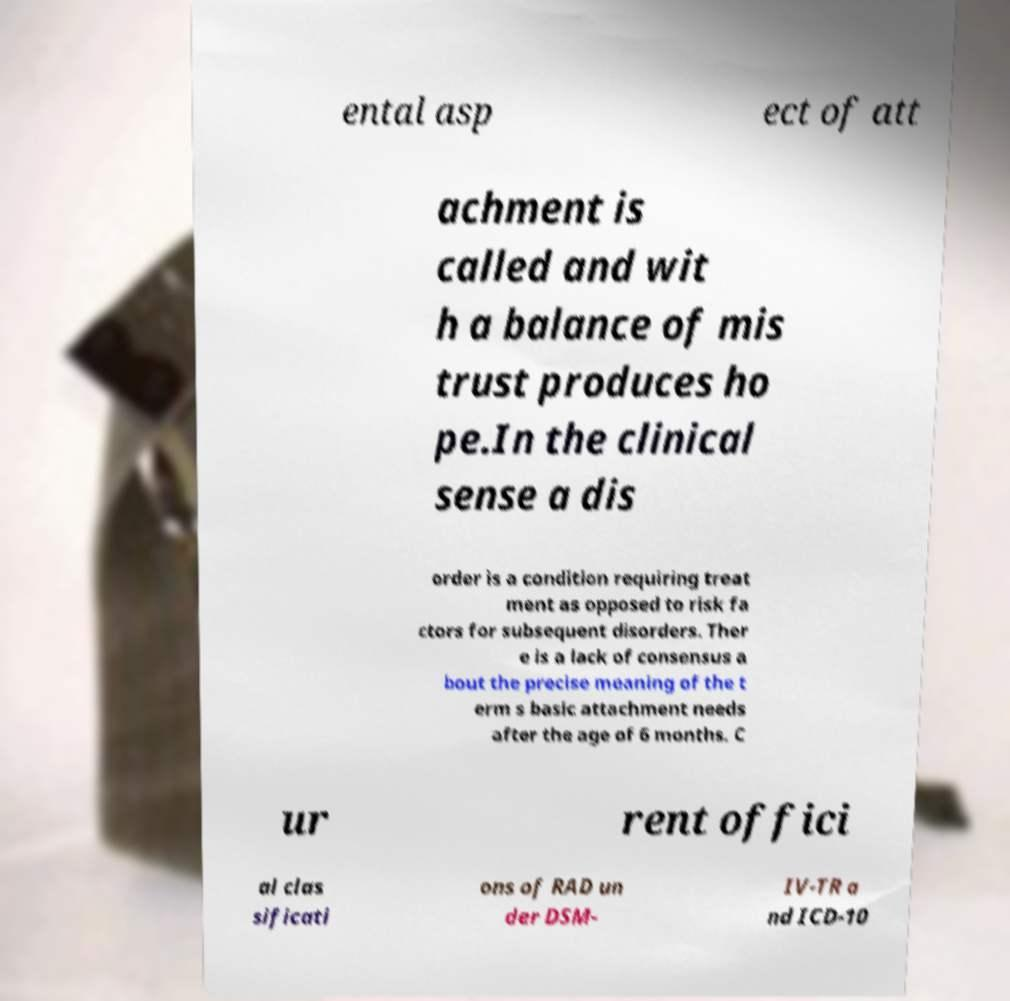I need the written content from this picture converted into text. Can you do that? ental asp ect of att achment is called and wit h a balance of mis trust produces ho pe.In the clinical sense a dis order is a condition requiring treat ment as opposed to risk fa ctors for subsequent disorders. Ther e is a lack of consensus a bout the precise meaning of the t erm s basic attachment needs after the age of 6 months. C ur rent offici al clas sificati ons of RAD un der DSM- IV-TR a nd ICD-10 